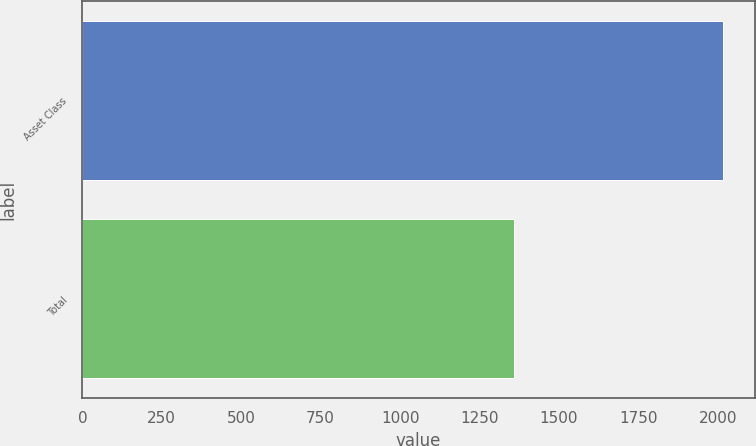<chart> <loc_0><loc_0><loc_500><loc_500><bar_chart><fcel>Asset Class<fcel>Total<nl><fcel>2015<fcel>1358<nl></chart> 